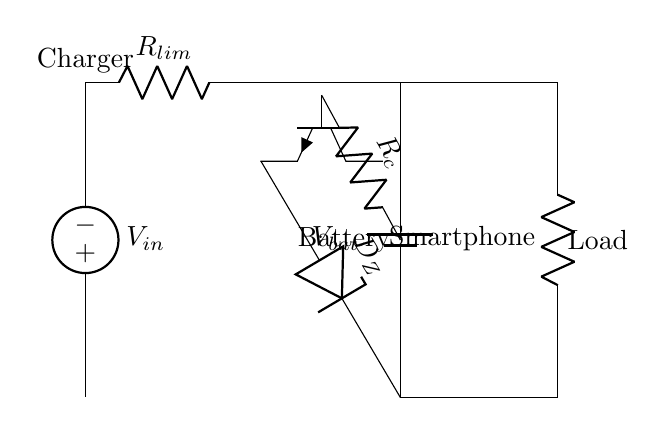What is the role of the Zener diode in this circuit? The Zener diode acts as a voltage clamp to ensure that the voltage does not exceed a certain threshold, thereby protecting the battery from overvoltage conditions during charging.
Answer: Voltage clamp What component limits the current to the smartphone? The current-limiting resistor, denoted as R_lm, restricts the maximum current that can flow into the smartphone battery during the charging process.
Answer: R_lm What is the power supply used in this circuit? The power supply is represented by the voltage source labeled V_in, which provides the necessary voltage for charging the battery.
Answer: V_in How does the transistor function in this circuit? The transistor, which is an NPN type, acts as a switch that controls the charging current based on the voltage at its base, influenced by the Zener diode and control resistor.
Answer: Switch What would happen if the current-limiting resistor is removed? Without the current-limiting resistor, the charging current may exceed safe levels, potentially damaging the smartphone battery due to overcurrent.
Answer: Damage What is the significance of the control resistor in this circuit? The control resistor, labeled as R_c, helps set the desired base current for the transistor, which in turn regulates how much current is allowed to flow to the battery.
Answer: Regulates base current 